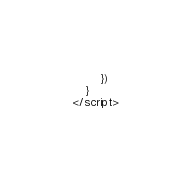<code> <loc_0><loc_0><loc_500><loc_500><_HTML_>        })
    }
</script></code> 